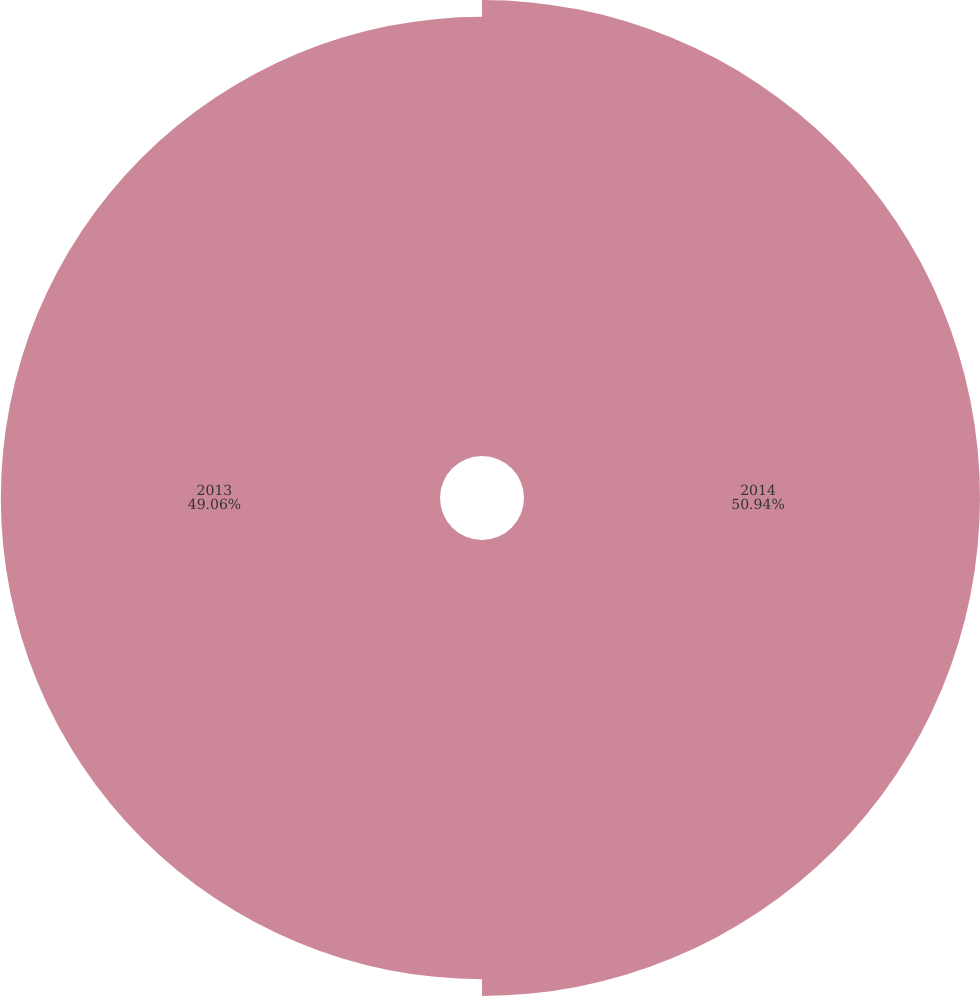Convert chart to OTSL. <chart><loc_0><loc_0><loc_500><loc_500><pie_chart><fcel>2014<fcel>2013<nl><fcel>50.94%<fcel>49.06%<nl></chart> 